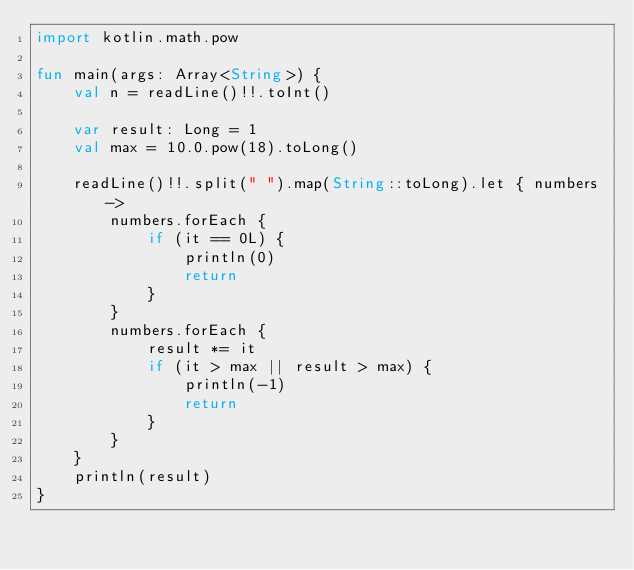Convert code to text. <code><loc_0><loc_0><loc_500><loc_500><_Kotlin_>import kotlin.math.pow

fun main(args: Array<String>) {
    val n = readLine()!!.toInt()

    var result: Long = 1
    val max = 10.0.pow(18).toLong()

    readLine()!!.split(" ").map(String::toLong).let { numbers ->
        numbers.forEach {
            if (it == 0L) {
                println(0)
                return
            }
        }
        numbers.forEach {
            result *= it
            if (it > max || result > max) {
                println(-1)
                return
            }
        }
    }
    println(result)
}</code> 